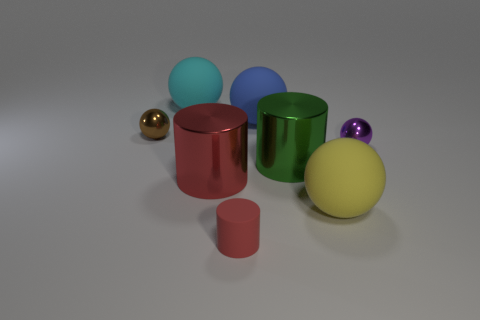Subtract all blue blocks. How many red cylinders are left? 2 Subtract all cyan spheres. How many spheres are left? 4 Subtract all purple metallic spheres. How many spheres are left? 4 Add 2 green shiny cylinders. How many objects exist? 10 Subtract all purple cylinders. Subtract all yellow spheres. How many cylinders are left? 3 Subtract all cylinders. How many objects are left? 5 Subtract all tiny brown metallic spheres. Subtract all yellow matte things. How many objects are left? 6 Add 8 big green metal objects. How many big green metal objects are left? 9 Add 8 large red cylinders. How many large red cylinders exist? 9 Subtract 0 purple cubes. How many objects are left? 8 